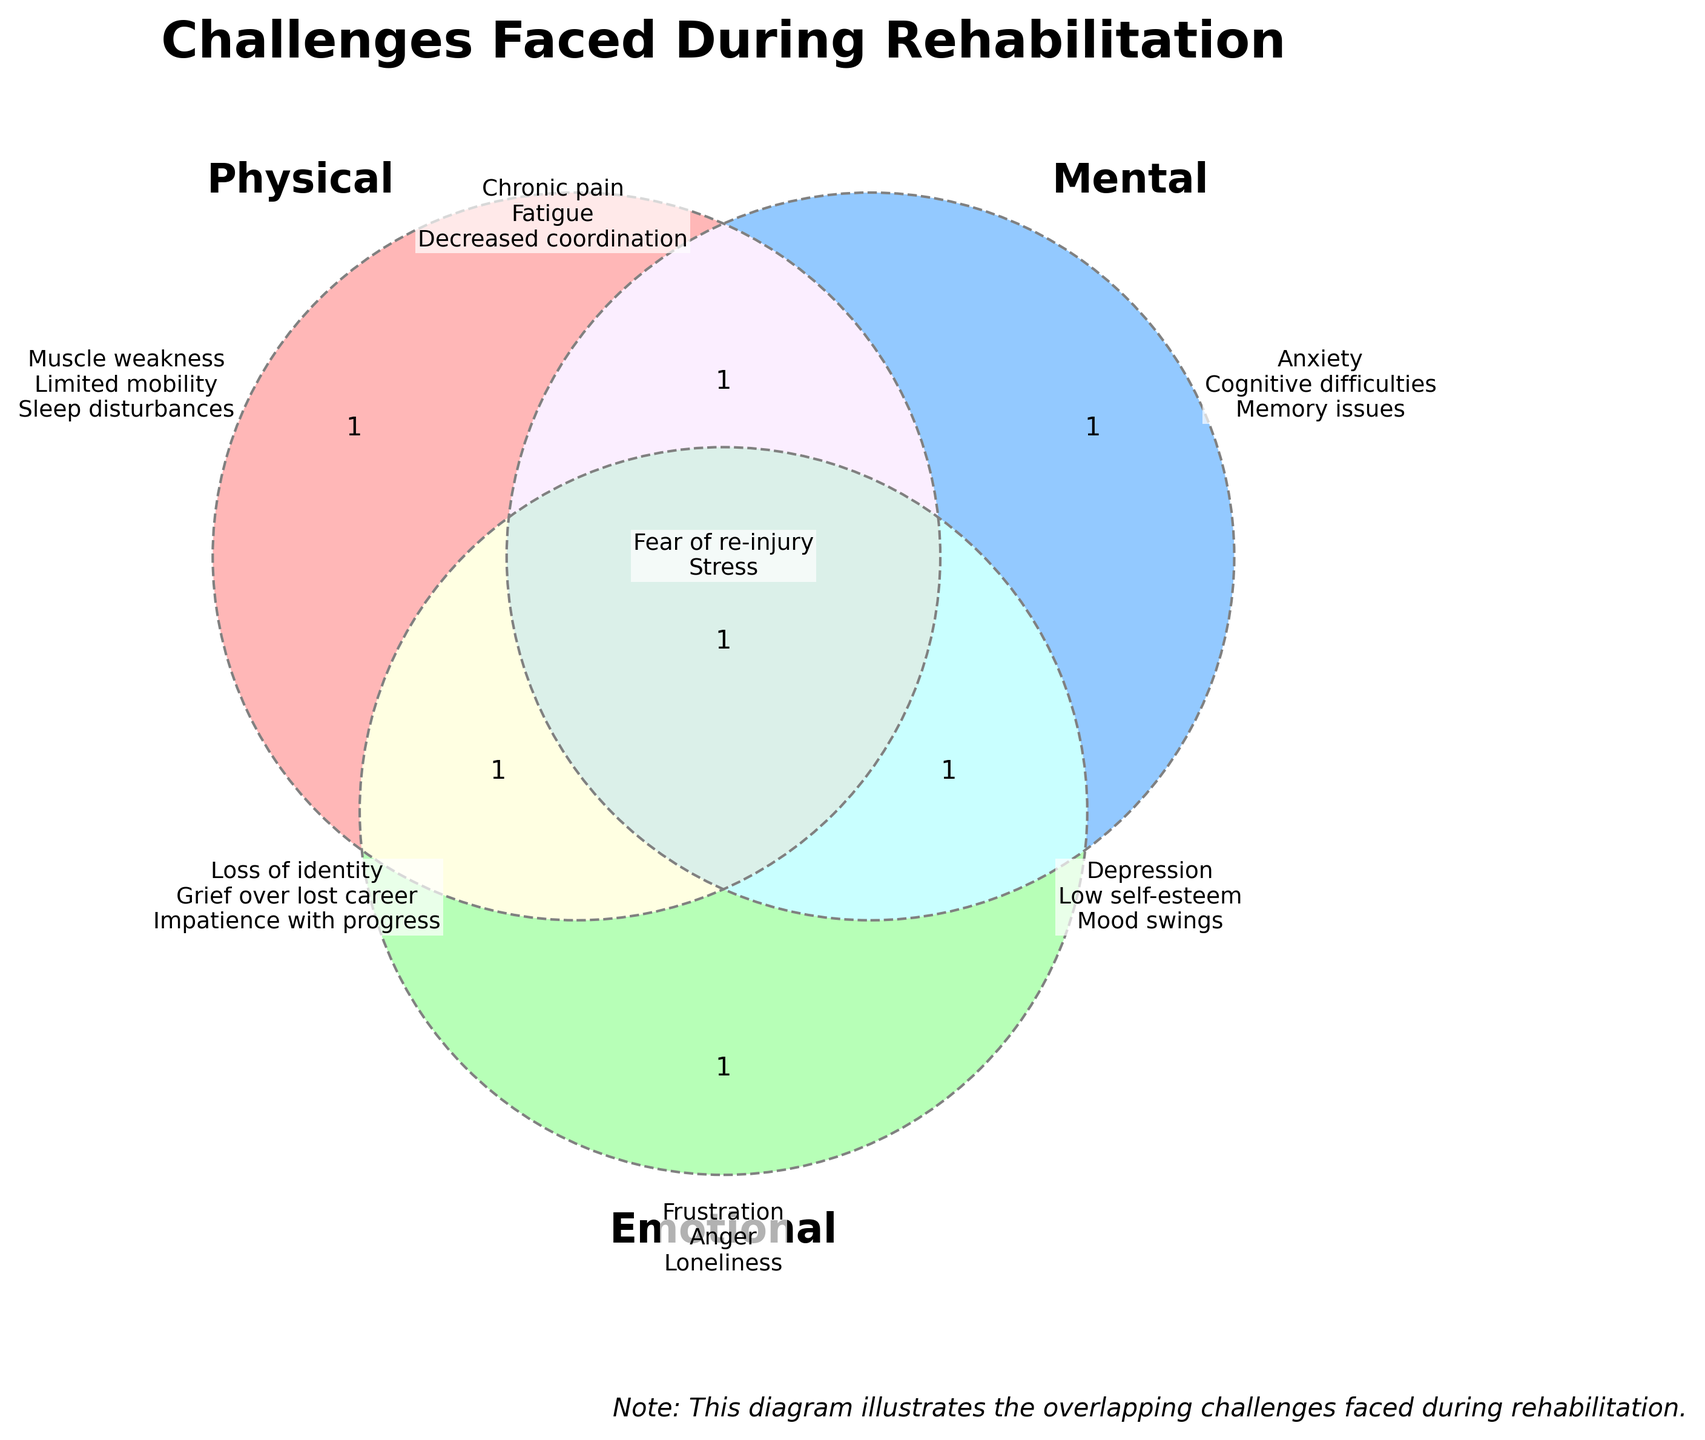Which challenges fall under only Physical issues? The single circle labeled "Physical" contains the challenges that fall under only Physical issues. The text in this section includes "Muscle weakness," "Limited mobility," and "Sleep disturbances."
Answer: Muscle weakness, Limited mobility, Sleep disturbances What is the title of the Venn Diagram? The title is located at the top of the figure. It reads "Challenges Faced During Rehabilitation."
Answer: Challenges Faced During Rehabilitation Which challenge is shared by all three categories: Physical, Mental, and Emotional? In the Venn diagram, the area where all three circles overlap is labeled "All." The text in this section includes "Fear of re-injury," "Stress," and "Mood swings."
Answer: Fear of re-injury, Stress, Mood swings How many challenges are categorized as both Physical and Mental? The intersection between the Physical and Mental circles shows two entries. Those entries are "Chronic pain" and "Fatigue."
Answer: Two What are some of the Emotional challenges listed? The single circle labeled "Emotional" holds the challenges for this category. The text in this section includes "Frustration," "Anger," and "Loneliness."
Answer: Frustration, Anger, Loneliness How many challenges fall under both Emotional and Mental categories, but not Physical? The overlap between Emotional and Mental circles, not including Physical, contains "Depression," "Low self-esteem," and "Impatience with progress." Hence, there are three challenges here.
Answer: Three Which Physical challenges also overlap with Emotional challenges? The Venn diagram section where Physical and Emotional circles overlap contains "Loss of identity" and "Grief over lost career."
Answer: Loss of identity, Grief over lost career Is "Sleep disturbances" a challenge shared with either Mental or Emotional categories? "Sleep disturbances" is found exclusively in the Physical section with no overlaps, which means it's not shared with either Mental or Emotional categories.
Answer: No Which category has challenges involving cognitive and memory issues? The Mental circle includes challenges related to cognitive difficulties and memory issues. These are labeled within the Mental section.
Answer: Mental category What are the challenges attributed to Physical & Mental but not Emotional? The area of overlap between Physical and Mental without including Emotional shows "Chronic pain" and "Fatigue." These are the challenges exclusive to these two intersections.
Answer: Chronic pain, Fatigue 